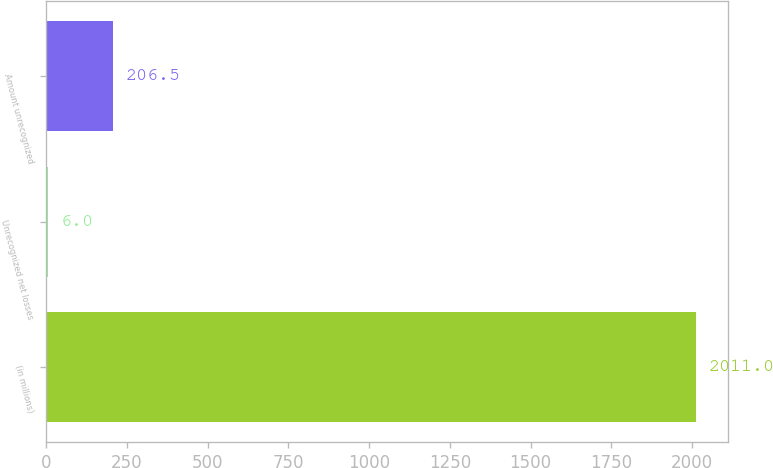Convert chart to OTSL. <chart><loc_0><loc_0><loc_500><loc_500><bar_chart><fcel>(in millions)<fcel>Unrecognized net losses<fcel>Amount unrecognized<nl><fcel>2011<fcel>6<fcel>206.5<nl></chart> 